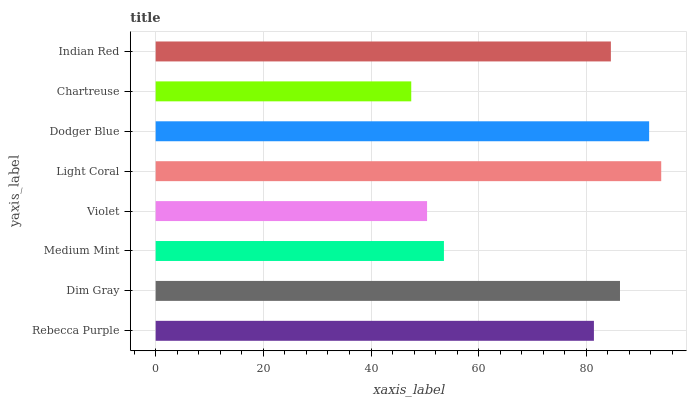Is Chartreuse the minimum?
Answer yes or no. Yes. Is Light Coral the maximum?
Answer yes or no. Yes. Is Dim Gray the minimum?
Answer yes or no. No. Is Dim Gray the maximum?
Answer yes or no. No. Is Dim Gray greater than Rebecca Purple?
Answer yes or no. Yes. Is Rebecca Purple less than Dim Gray?
Answer yes or no. Yes. Is Rebecca Purple greater than Dim Gray?
Answer yes or no. No. Is Dim Gray less than Rebecca Purple?
Answer yes or no. No. Is Indian Red the high median?
Answer yes or no. Yes. Is Rebecca Purple the low median?
Answer yes or no. Yes. Is Dim Gray the high median?
Answer yes or no. No. Is Violet the low median?
Answer yes or no. No. 